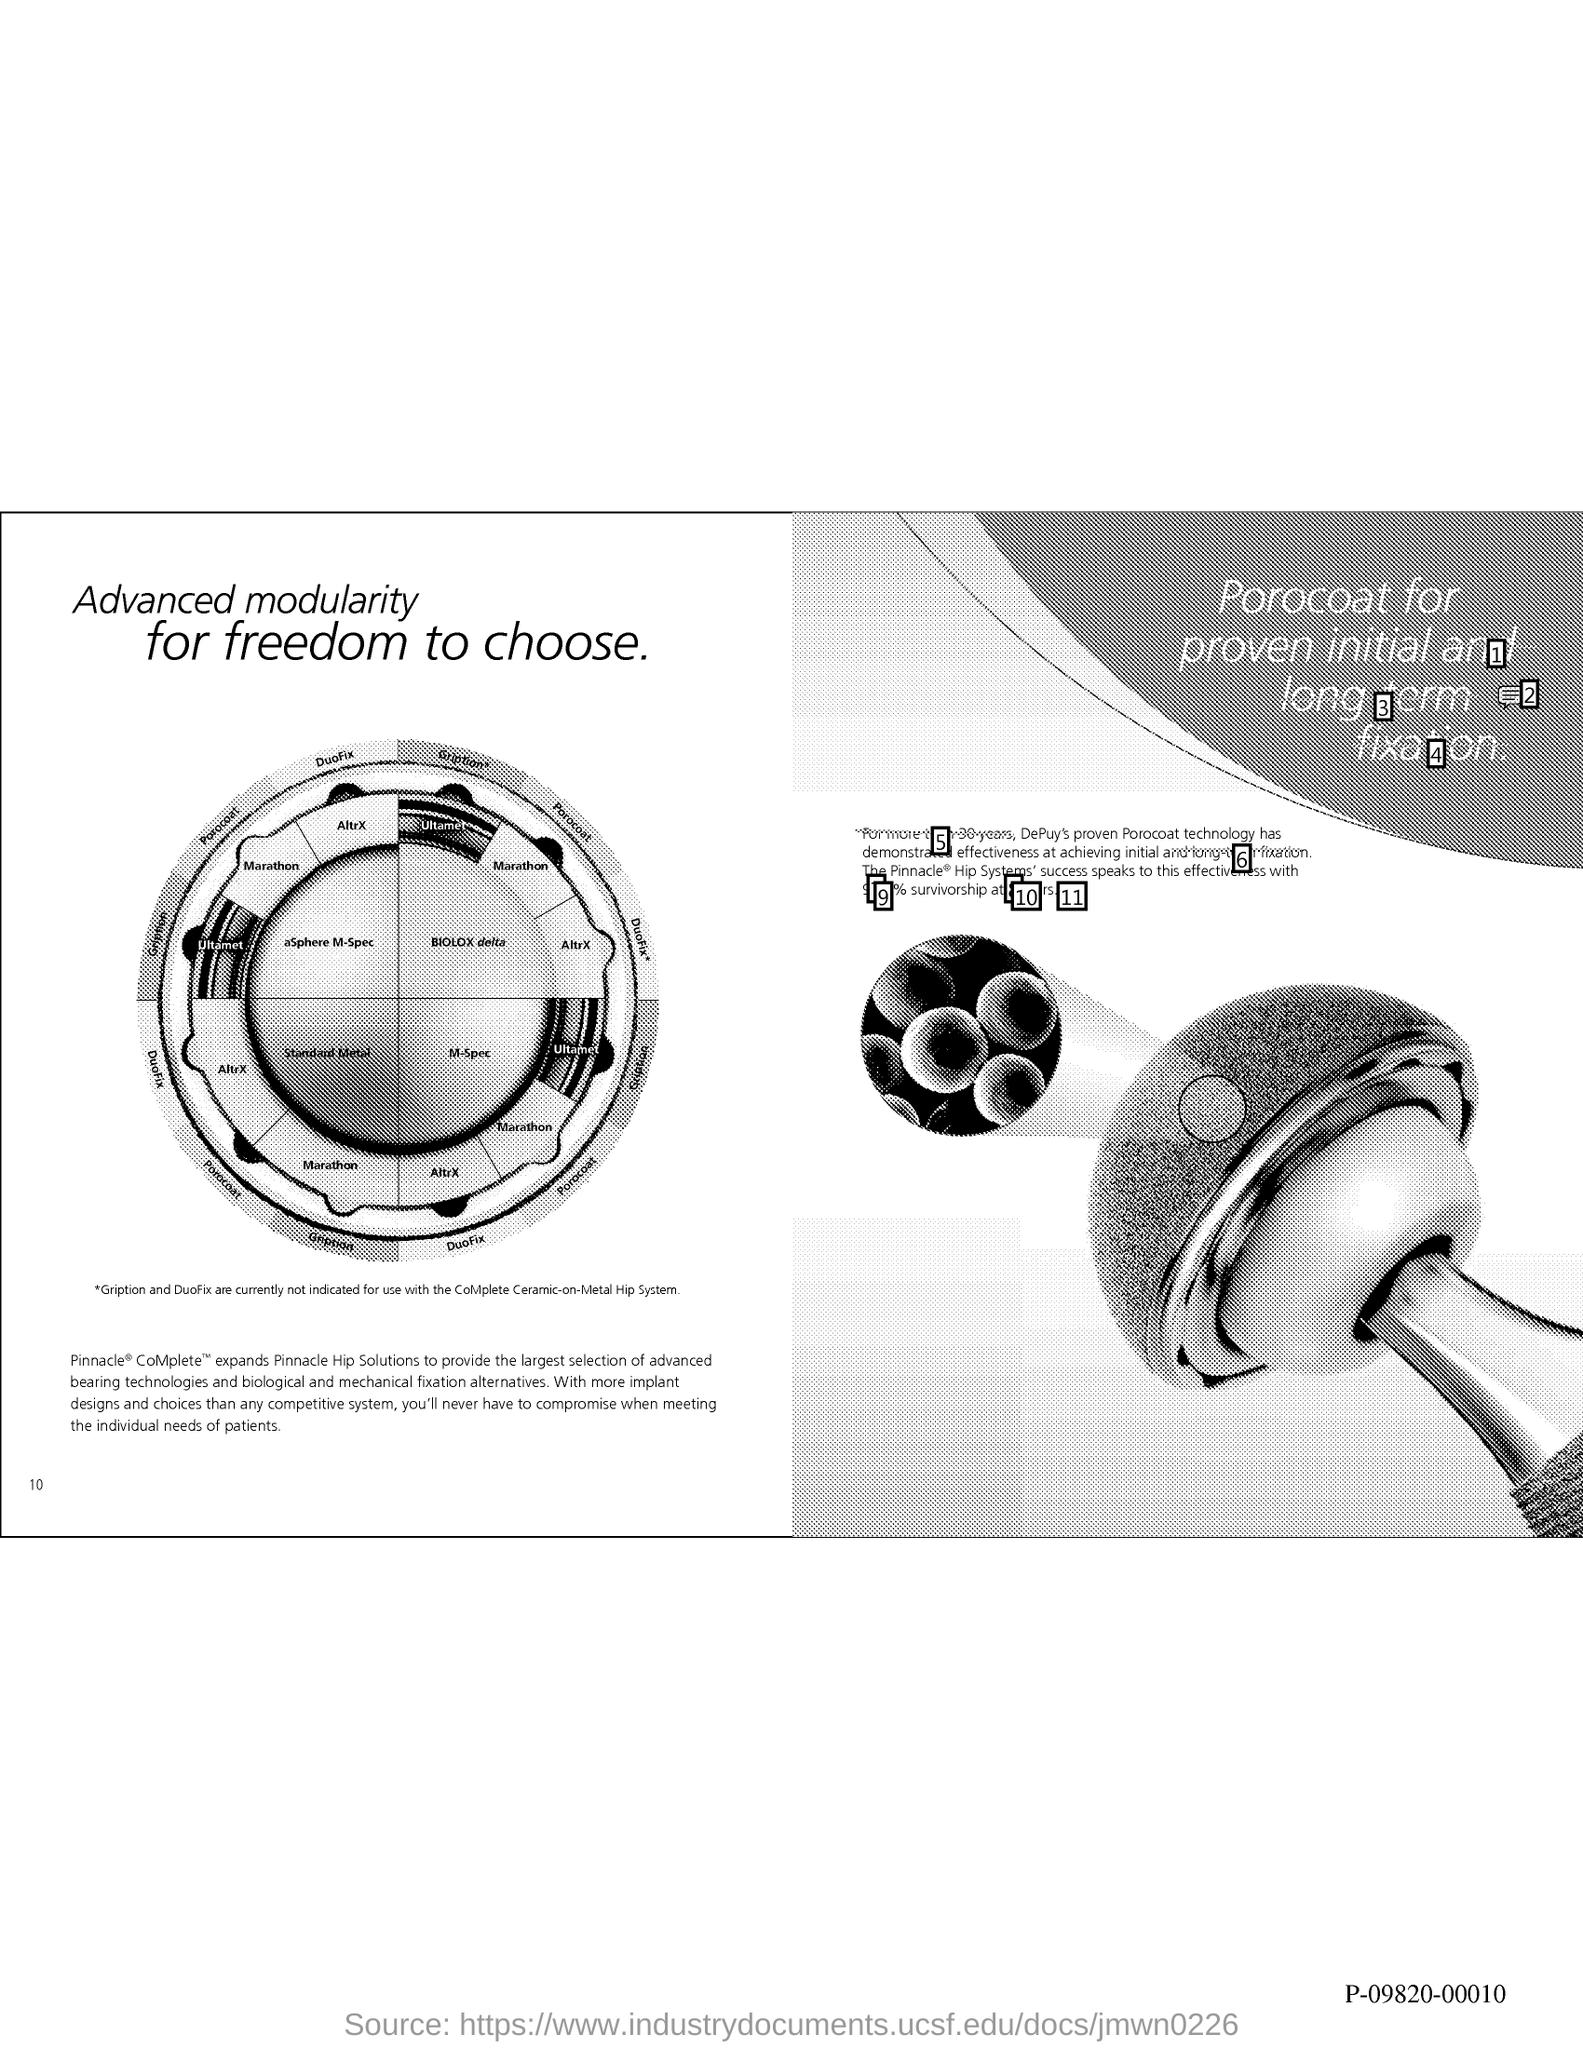List a handful of essential elements in this visual. The page number is 10, as declared. 